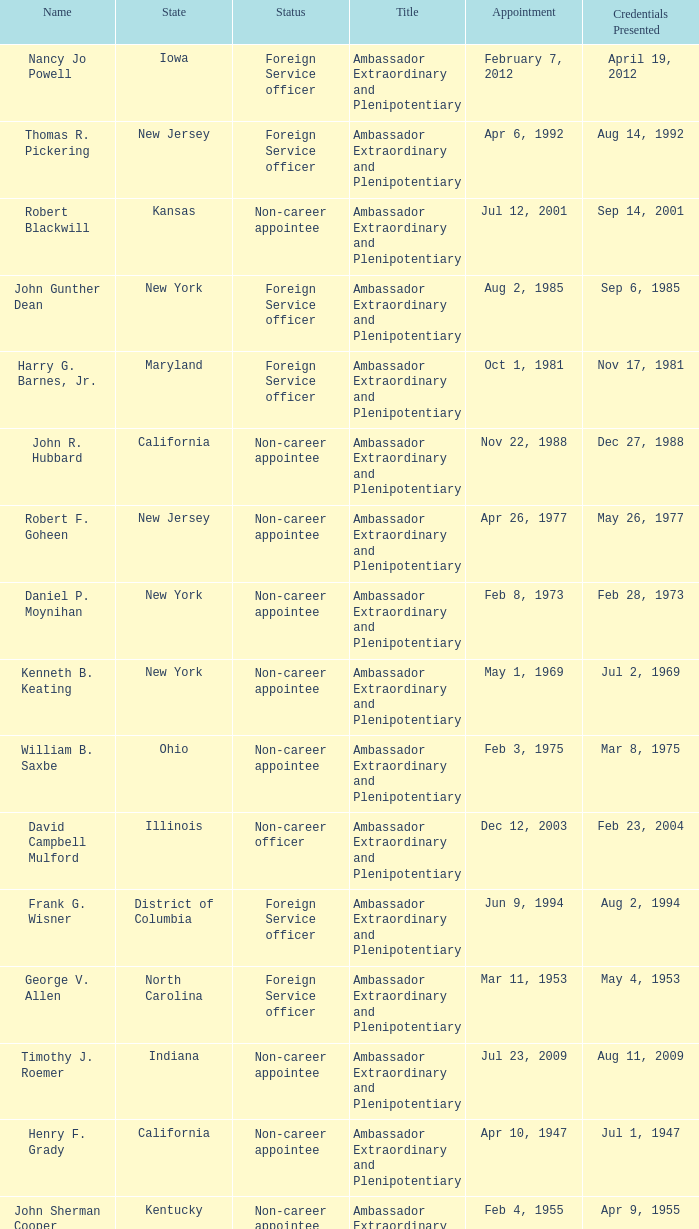Can you give me this table as a dict? {'header': ['Name', 'State', 'Status', 'Title', 'Appointment', 'Credentials Presented'], 'rows': [['Nancy Jo Powell', 'Iowa', 'Foreign Service officer', 'Ambassador Extraordinary and Plenipotentiary', 'February 7, 2012', 'April 19, 2012'], ['Thomas R. Pickering', 'New Jersey', 'Foreign Service officer', 'Ambassador Extraordinary and Plenipotentiary', 'Apr 6, 1992', 'Aug 14, 1992'], ['Robert Blackwill', 'Kansas', 'Non-career appointee', 'Ambassador Extraordinary and Plenipotentiary', 'Jul 12, 2001', 'Sep 14, 2001'], ['John Gunther Dean', 'New York', 'Foreign Service officer', 'Ambassador Extraordinary and Plenipotentiary', 'Aug 2, 1985', 'Sep 6, 1985'], ['Harry G. Barnes, Jr.', 'Maryland', 'Foreign Service officer', 'Ambassador Extraordinary and Plenipotentiary', 'Oct 1, 1981', 'Nov 17, 1981'], ['John R. Hubbard', 'California', 'Non-career appointee', 'Ambassador Extraordinary and Plenipotentiary', 'Nov 22, 1988', 'Dec 27, 1988'], ['Robert F. Goheen', 'New Jersey', 'Non-career appointee', 'Ambassador Extraordinary and Plenipotentiary', 'Apr 26, 1977', 'May 26, 1977'], ['Daniel P. Moynihan', 'New York', 'Non-career appointee', 'Ambassador Extraordinary and Plenipotentiary', 'Feb 8, 1973', 'Feb 28, 1973'], ['Kenneth B. Keating', 'New York', 'Non-career appointee', 'Ambassador Extraordinary and Plenipotentiary', 'May 1, 1969', 'Jul 2, 1969'], ['William B. Saxbe', 'Ohio', 'Non-career appointee', 'Ambassador Extraordinary and Plenipotentiary', 'Feb 3, 1975', 'Mar 8, 1975'], ['David Campbell Mulford', 'Illinois', 'Non-career officer', 'Ambassador Extraordinary and Plenipotentiary', 'Dec 12, 2003', 'Feb 23, 2004'], ['Frank G. Wisner', 'District of Columbia', 'Foreign Service officer', 'Ambassador Extraordinary and Plenipotentiary', 'Jun 9, 1994', 'Aug 2, 1994'], ['George V. Allen', 'North Carolina', 'Foreign Service officer', 'Ambassador Extraordinary and Plenipotentiary', 'Mar 11, 1953', 'May 4, 1953'], ['Timothy J. Roemer', 'Indiana', 'Non-career appointee', 'Ambassador Extraordinary and Plenipotentiary', 'Jul 23, 2009', 'Aug 11, 2009'], ['Henry F. Grady', 'California', 'Non-career appointee', 'Ambassador Extraordinary and Plenipotentiary', 'Apr 10, 1947', 'Jul 1, 1947'], ['John Sherman Cooper', 'Kentucky', 'Non-career appointee', 'Ambassador Extraordinary and Plenipotentiary', 'Feb 4, 1955', 'Apr 9, 1955'], ['Chester Bowles', 'Connecticut', 'Non-career appointee', 'Ambassador Extraordinary and Plenipotentiary', 'May 3, 1963', 'Jul 19, 1963'], ['William Clark, Jr.', 'District of Columbia', 'Foreign Service officer', 'Ambassador Extraordinary and Plenipotentiary', 'Oct 10, 1989', 'Dec 22, 1989'], ['Loy W. Henderson', 'Colorado', 'Foreign Service officer', 'Ambassador Extraordinary and Plenipotentiary', 'Jul 14, 1948', 'Nov 19, 1948'], ['Albert Peter Burleigh', 'California', 'Foreign Service officer', "Charge d'affaires", 'June 2011', 'Left post 2012'], ['Richard Frank Celeste', 'Ohio', 'Non-career appointee', 'Ambassador Extraordinary and Plenipotentiary', 'Nov 10, 1997', 'Nov 28, 1997'], ['John Kenneth Galbraith', 'Massachusetts', 'Non-career appointee', 'Ambassador Extraordinary and Plenipotentiary', 'Mar 29, 1961', 'Apr 18, 1961'], ['Ellsworth Bunker', 'Vermont', 'Non-career appointee', 'Ambassador Extraordinary and Plenipotentiary', 'Nov 28, 1956', 'Mar 4, 1957'], ['Chester Bowles', 'Connecticut', 'Non-career appointee', 'Ambassador Extraordinary and Plenipotentiary', 'Oct 10, 1951', 'Nov 1, 1951']]} What day were credentials presented for vermont? Mar 4, 1957. 